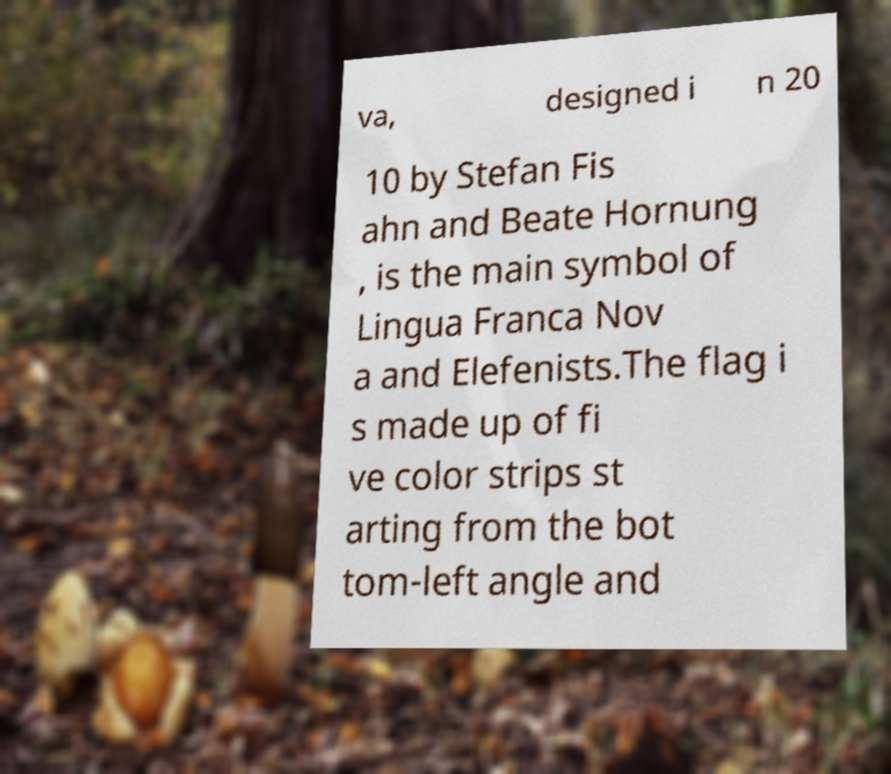I need the written content from this picture converted into text. Can you do that? va, designed i n 20 10 by Stefan Fis ahn and Beate Hornung , is the main symbol of Lingua Franca Nov a and Elefenists.The flag i s made up of fi ve color strips st arting from the bot tom-left angle and 